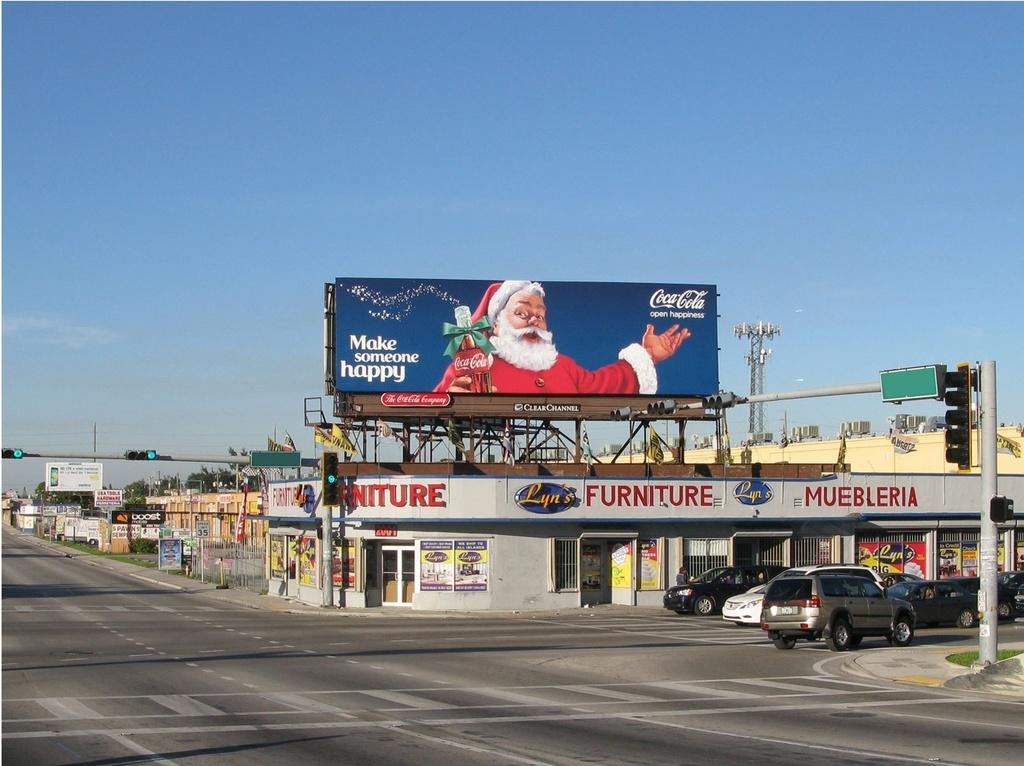What brand of drink is on the billboard?
Provide a succinct answer. Coca cola. Does the store on the bottom sell furniture?
Provide a short and direct response. Yes. 